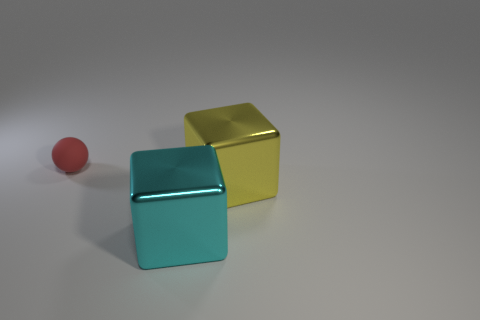Add 2 large yellow things. How many objects exist? 5 Subtract all blocks. How many objects are left? 1 Add 2 small rubber spheres. How many small rubber spheres are left? 3 Add 3 big blue metallic objects. How many big blue metallic objects exist? 3 Subtract 0 purple cubes. How many objects are left? 3 Subtract all tiny metal spheres. Subtract all metal blocks. How many objects are left? 1 